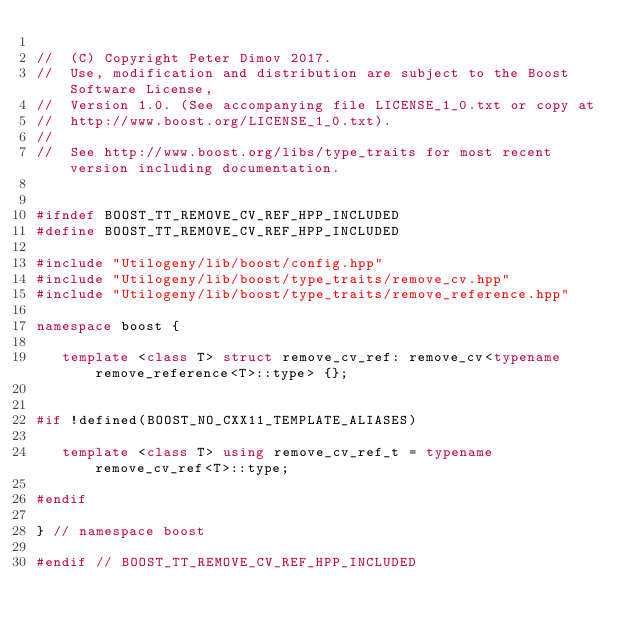<code> <loc_0><loc_0><loc_500><loc_500><_C++_>
//  (C) Copyright Peter Dimov 2017. 
//  Use, modification and distribution are subject to the Boost Software License,
//  Version 1.0. (See accompanying file LICENSE_1_0.txt or copy at
//  http://www.boost.org/LICENSE_1_0.txt).
//
//  See http://www.boost.org/libs/type_traits for most recent version including documentation.


#ifndef BOOST_TT_REMOVE_CV_REF_HPP_INCLUDED
#define BOOST_TT_REMOVE_CV_REF_HPP_INCLUDED

#include "Utilogeny/lib/boost/config.hpp"
#include "Utilogeny/lib/boost/type_traits/remove_cv.hpp"
#include "Utilogeny/lib/boost/type_traits/remove_reference.hpp"

namespace boost {

   template <class T> struct remove_cv_ref: remove_cv<typename remove_reference<T>::type> {};


#if !defined(BOOST_NO_CXX11_TEMPLATE_ALIASES)

   template <class T> using remove_cv_ref_t = typename remove_cv_ref<T>::type;

#endif

} // namespace boost

#endif // BOOST_TT_REMOVE_CV_REF_HPP_INCLUDED
</code> 